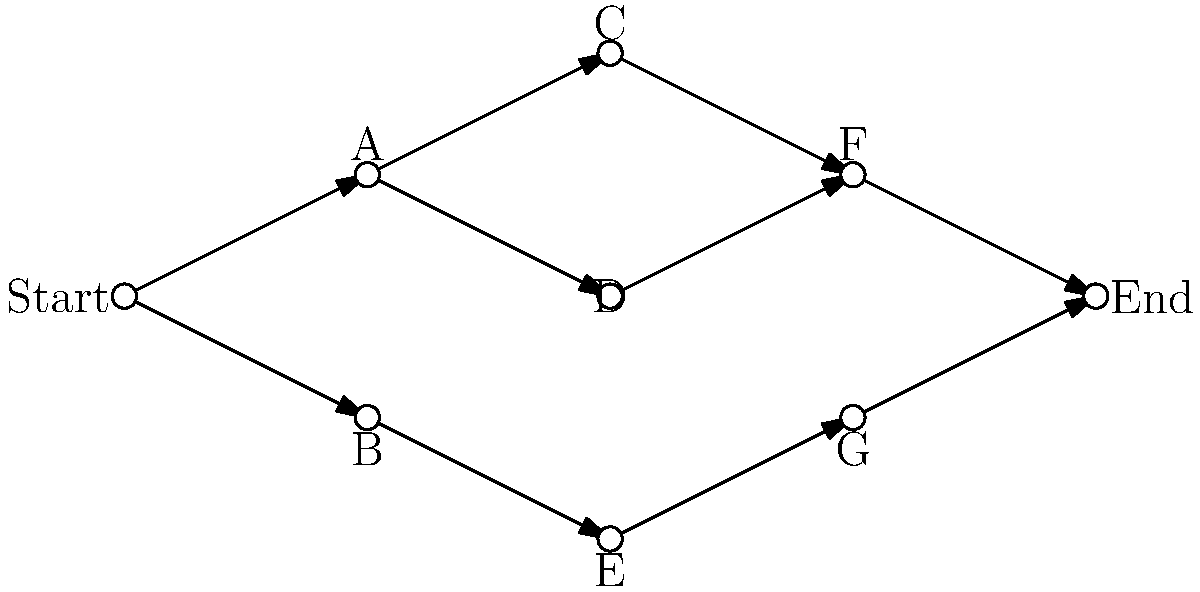In the customer journey map shown above, how many unique paths can a customer take from the Start node to the End node? To determine the number of unique paths from Start to End, we'll follow these steps:

1. Identify all possible paths:
   - Start → A → C → F → End
   - Start → A → D → F → End
   - Start → A → C → F → End
   - Start → B → E → G → End

2. Count the number of unique paths:
   a) Start → A → C → F → End
   b) Start → A → D → F → End
   c) Start → B → E → G → End

3. Verify that each path is distinct:
   - Path (a) and (b) differ at nodes C and D
   - Path (c) is entirely different from (a) and (b)

4. Sum up the total number of unique paths:
   Total unique paths = 3

This customer journey map shows three distinct ways a customer can move from the initial touchpoint (Start) to the final conversion (End), representing different decision points and interactions throughout the marketing funnel.
Answer: 3 unique paths 